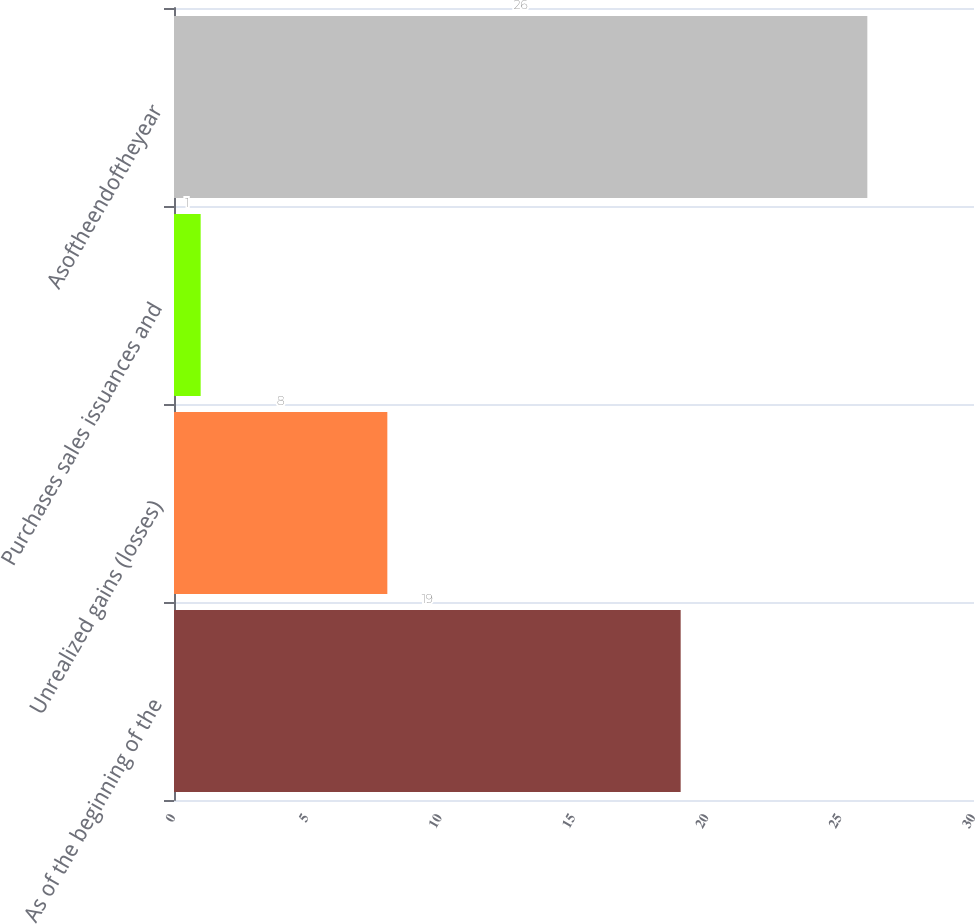<chart> <loc_0><loc_0><loc_500><loc_500><bar_chart><fcel>As of the beginning of the<fcel>Unrealized gains (losses)<fcel>Purchases sales issuances and<fcel>Asoftheendoftheyear<nl><fcel>19<fcel>8<fcel>1<fcel>26<nl></chart> 